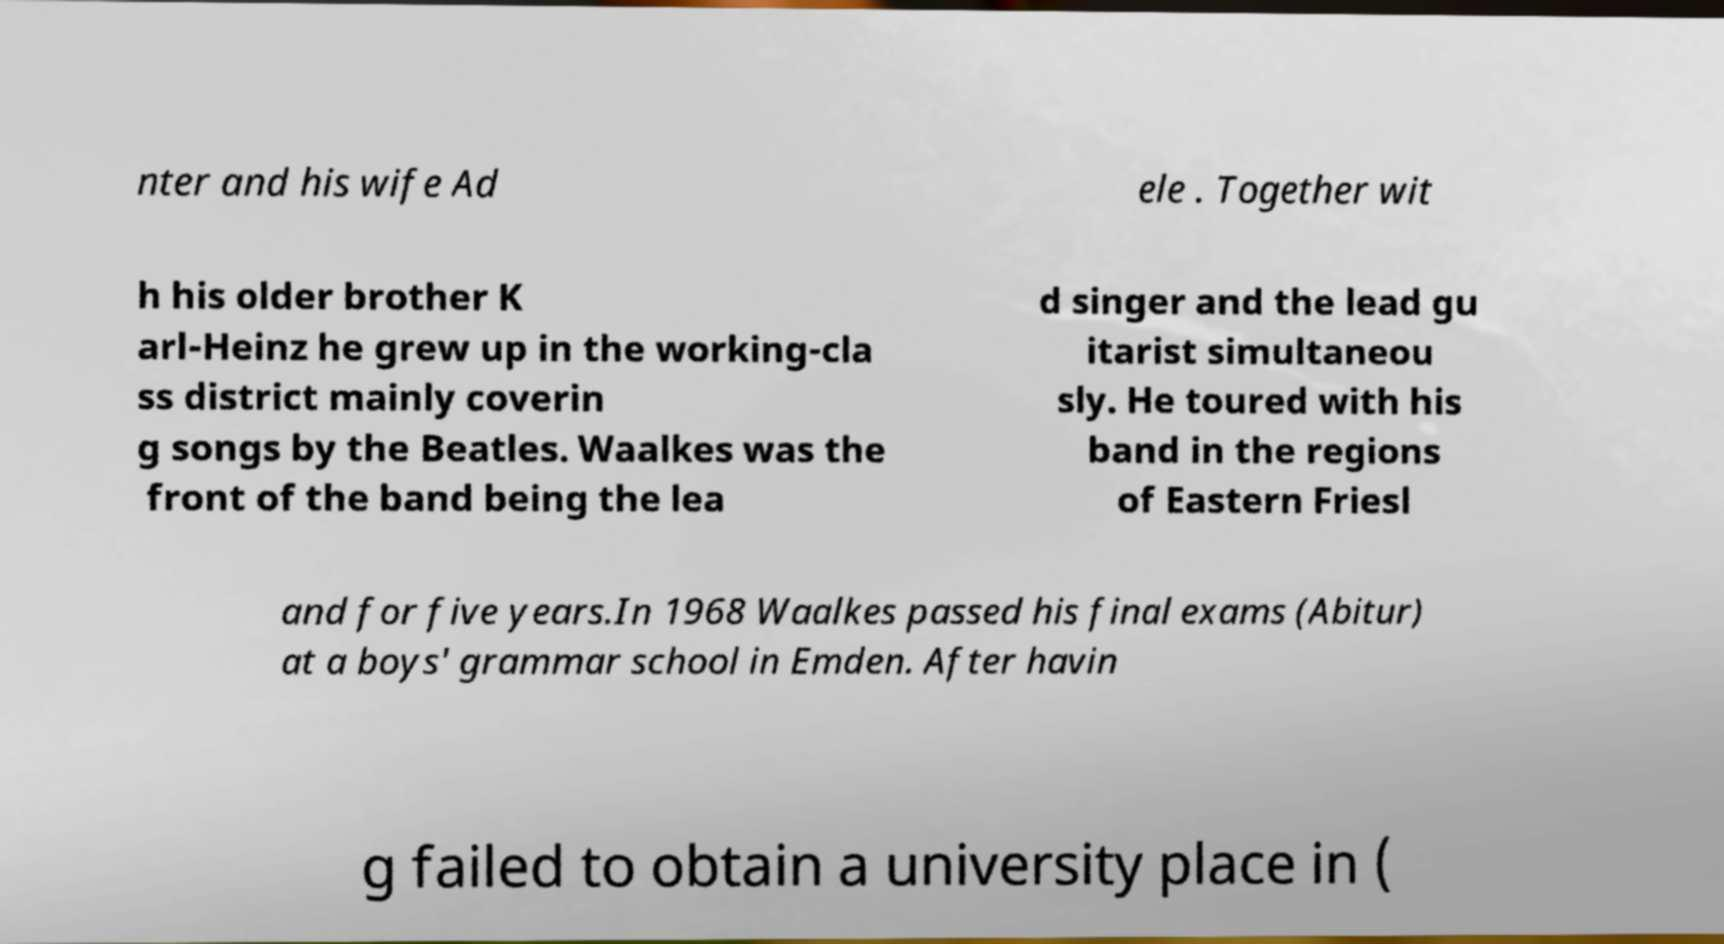There's text embedded in this image that I need extracted. Can you transcribe it verbatim? nter and his wife Ad ele . Together wit h his older brother K arl-Heinz he grew up in the working-cla ss district mainly coverin g songs by the Beatles. Waalkes was the front of the band being the lea d singer and the lead gu itarist simultaneou sly. He toured with his band in the regions of Eastern Friesl and for five years.In 1968 Waalkes passed his final exams (Abitur) at a boys' grammar school in Emden. After havin g failed to obtain a university place in ( 